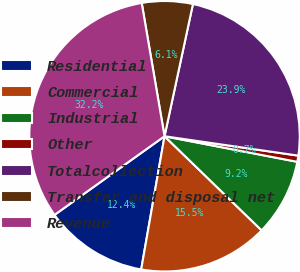Convert chart to OTSL. <chart><loc_0><loc_0><loc_500><loc_500><pie_chart><fcel>Residential<fcel>Commercial<fcel>Industrial<fcel>Other<fcel>Totalcollection<fcel>Transfer and disposal net<fcel>Revenue<nl><fcel>12.36%<fcel>15.51%<fcel>9.22%<fcel>0.74%<fcel>23.92%<fcel>6.07%<fcel>32.18%<nl></chart> 